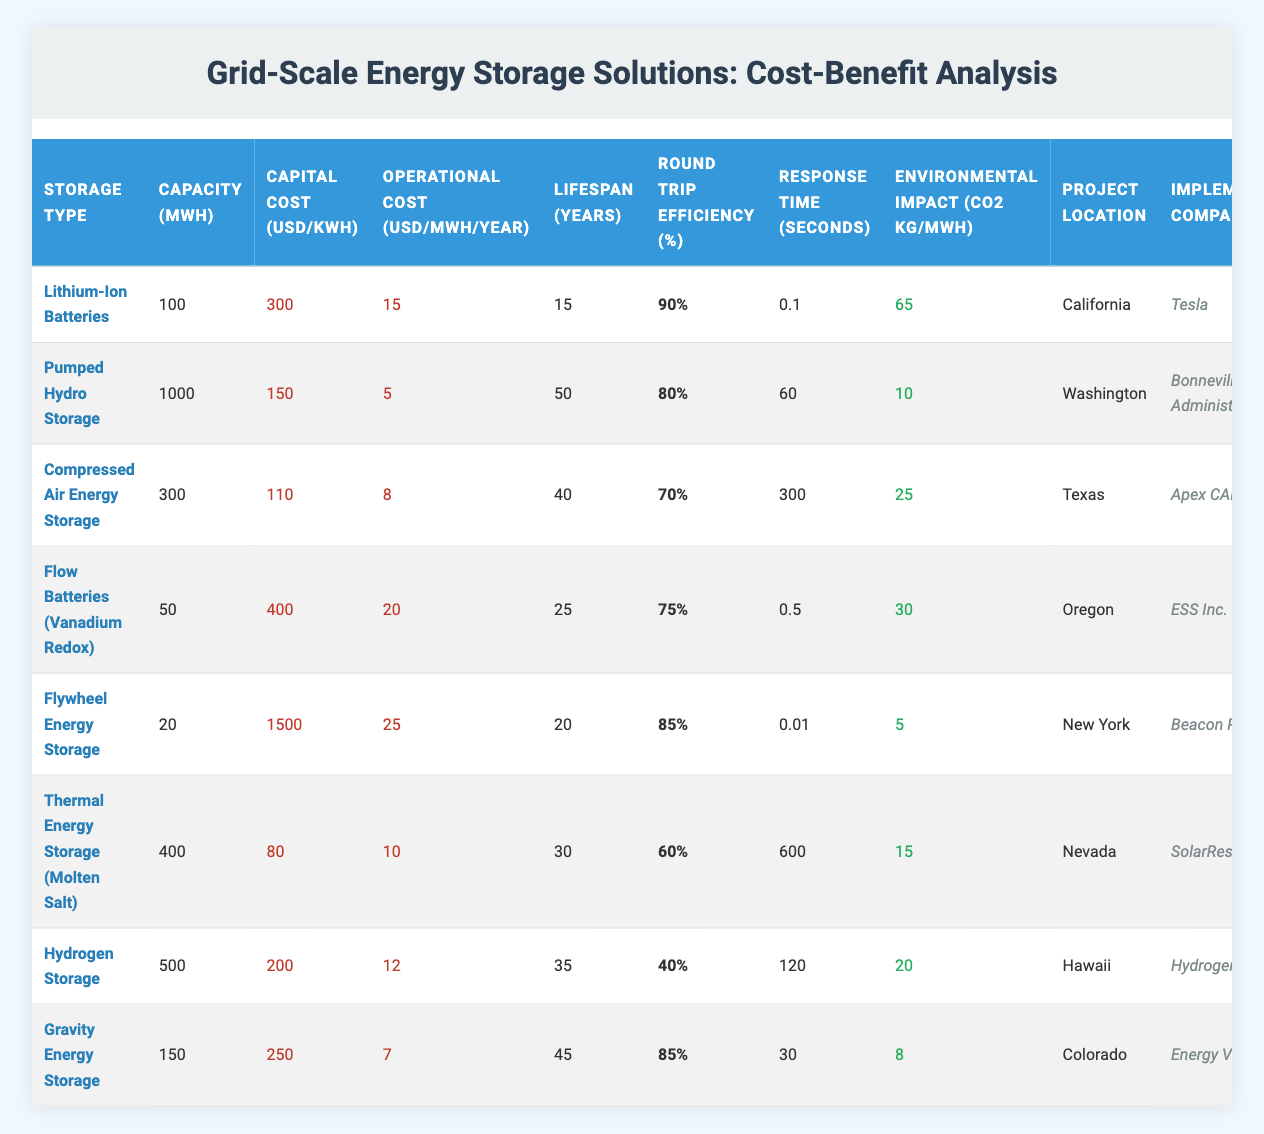What is the capital cost per kWh of Flywheel Energy Storage? The capital cost per kWh for Flywheel Energy Storage is listed as 1500 USD/kWh in the table.
Answer: 1500 USD/kWh What is the round trip efficiency of Thermal Energy Storage (Molten Salt)? According to the table, the round trip efficiency for Thermal Energy Storage (Molten Salt) is 60%.
Answer: 60% Which energy storage solution has the longest lifespan? By comparing the lifespan values, Pumped Hydro Storage has the longest lifespan at 50 years as shown in the table.
Answer: 50 years Is the operational cost of Hydrogen Storage lower than that of Flywheel Energy Storage? The operational cost for Hydrogen Storage is 12 USD/MWh/year, while Flywheel Energy Storage has an operational cost of 25 USD/MWh/year. Since 12 is less than 25, the answer is yes.
Answer: Yes What is the average capital cost per kWh of all storage solutions listed? To find the average capital cost per kWh, first, sum the capital costs: (300 + 150 + 110 + 400 + 1500 + 80 + 200 + 250) = 2990. Then, divide by the total number of solutions (8): 2990 / 8 = 373.75.
Answer: 373.75 USD/kWh Which storage options have a response time of less than 1 second? The only option listed with a response time of less than 1 second is Flywheel Energy Storage, with a response time of 0.01 seconds, as checked in the table.
Answer: Flywheel Energy Storage How many energy storage solutions have round trip efficiency percentages above 80%? Upon checking, there are four energy storage solutions with round trip efficiency above 80%: Lithium-Ion Batteries (90%), Flywheel Energy Storage (85%), and Gravity Energy Storage (85%).
Answer: 4 storage solutions What is the environmental impact (in CO2 kg per MWh) of Pumped Hydro Storage? The environmental impact of Pumped Hydro Storage is listed as 10 kg of CO2 per MWh in the table.
Answer: 10 kg/MWh Which storage solution has the lowest operational cost? The table shows that Pumped Hydro Storage has the lowest operational cost at 5 USD/MWh/year.
Answer: 5 USD/MWh/year 